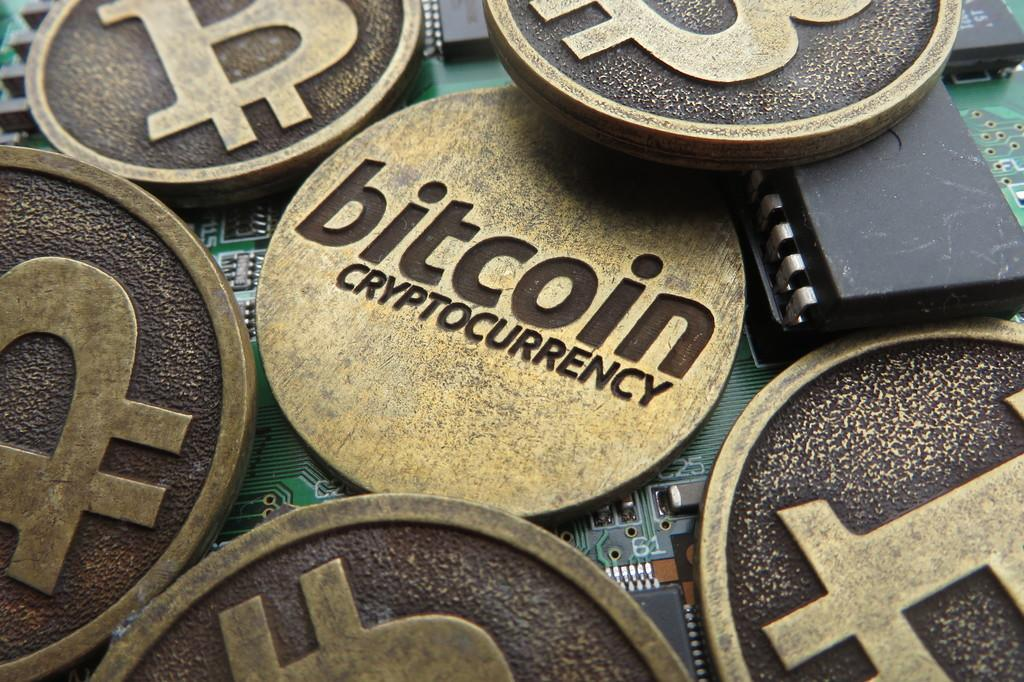Provide a one-sentence caption for the provided image. Units of bitcoin cryptocurrency are scattered across a computer circuit board. 